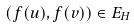<formula> <loc_0><loc_0><loc_500><loc_500>( f ( u ) , f ( v ) ) \in E _ { H }</formula> 